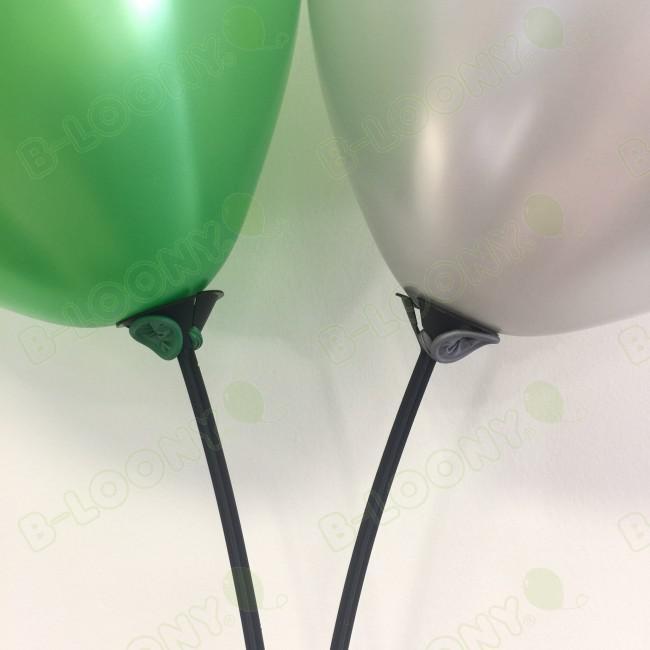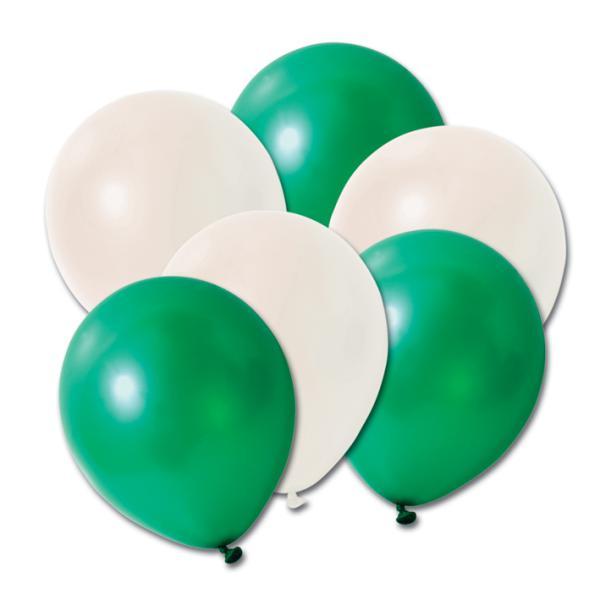The first image is the image on the left, the second image is the image on the right. Evaluate the accuracy of this statement regarding the images: "there are plastick baloon holders insteas of ribbons". Is it true? Answer yes or no. Yes. 